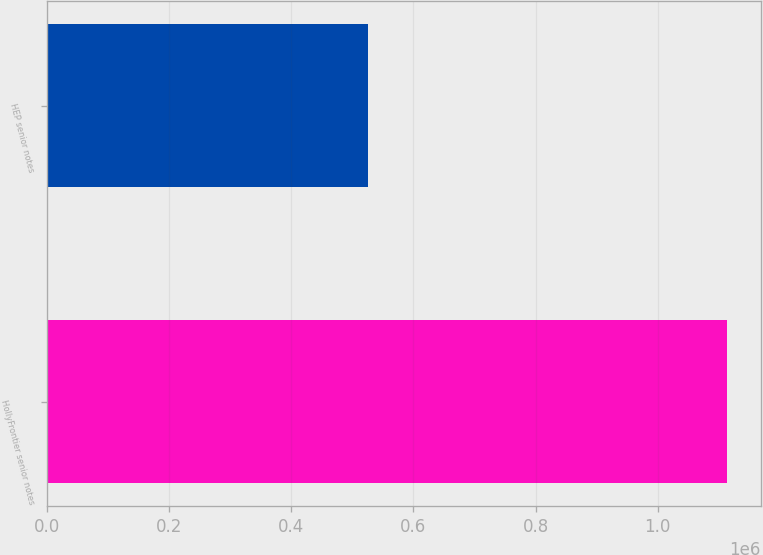Convert chart. <chart><loc_0><loc_0><loc_500><loc_500><bar_chart><fcel>HollyFrontier senior notes<fcel>HEP senior notes<nl><fcel>1.11347e+06<fcel>525120<nl></chart> 